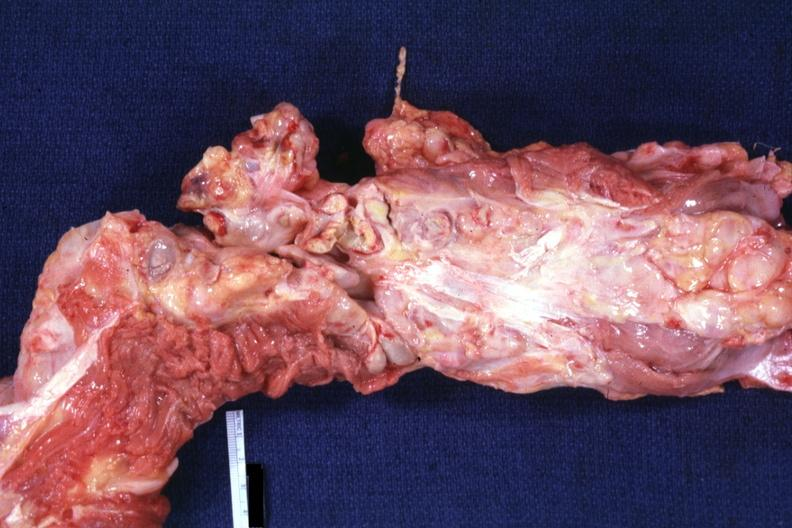s aorta not opened surrounded by large nodes?
Answer the question using a single word or phrase. Yes 